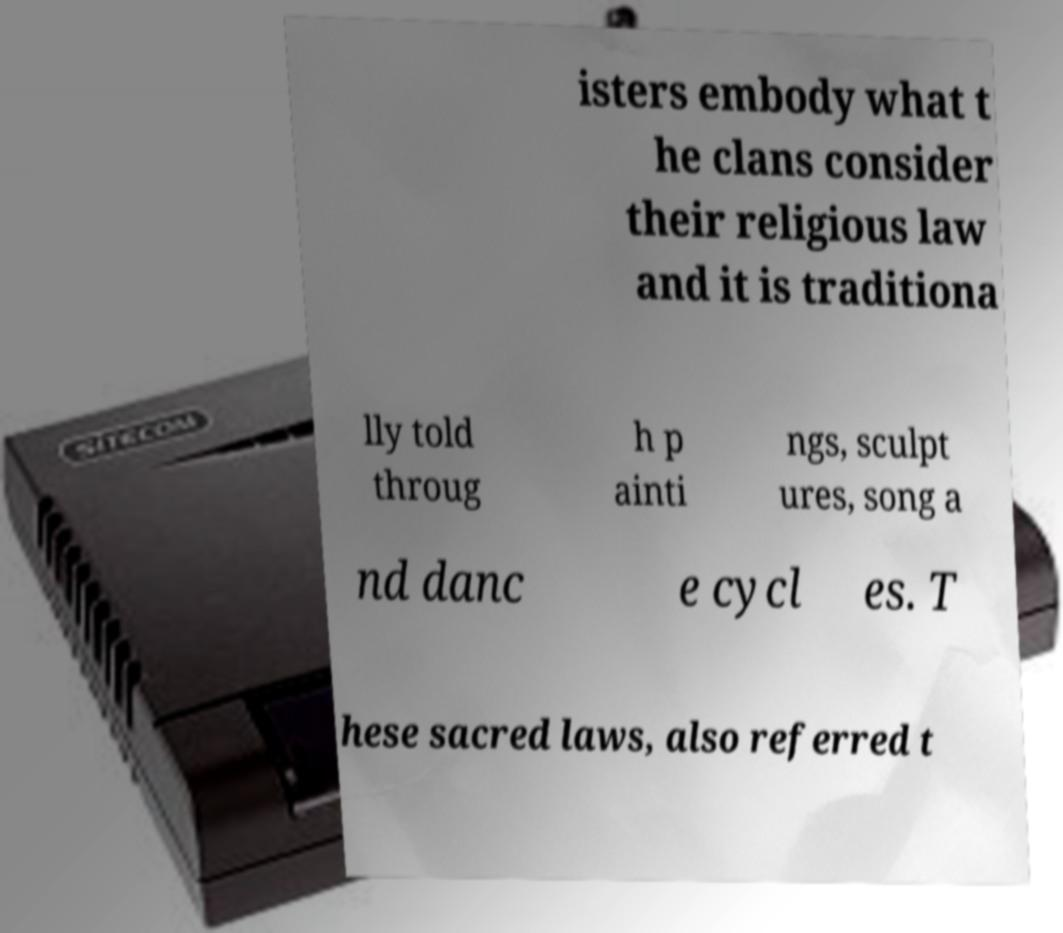I need the written content from this picture converted into text. Can you do that? isters embody what t he clans consider their religious law and it is traditiona lly told throug h p ainti ngs, sculpt ures, song a nd danc e cycl es. T hese sacred laws, also referred t 